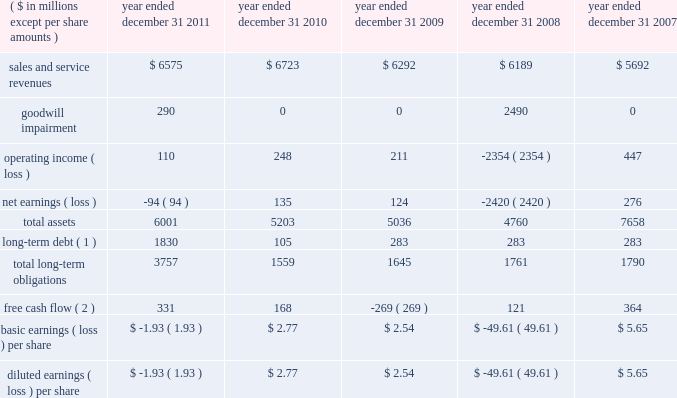( 1 ) the cumulative total return assumes reinvestment of dividends .
( 2 ) the total return is weighted according to market capitalization of each company at the beginning of each year .
( f ) purchases of equity securities by the issuer and affiliated purchasers we have not repurchased any of our common stock since the company filed its initial registration statement on march 16 , ( g ) securities authorized for issuance under equity compensation plans a description of securities authorized for issuance under our equity compensation plans will be incorporated herein by reference to the proxy statement for the 2012 annual meeting of stockholders to be filed within 120 days after the end of the company 2019s fiscal year .
Item 6 .
Selected financial data .
( 1 ) long-term debt does not include amounts payable to our former parent as of and before december 31 , 2010 , as these amounts were due upon demand and included in current liabilities .
( 2 ) free cash flow is a non-gaap financial measure and represents cash from operating activities less capital expenditures .
See liquidity and capital resources in item 7 for more information on this measure. .
What was the increase in free cash flow achieved during 2011? 
Computations: ((331 - 168) / 168)
Answer: 0.97024. 